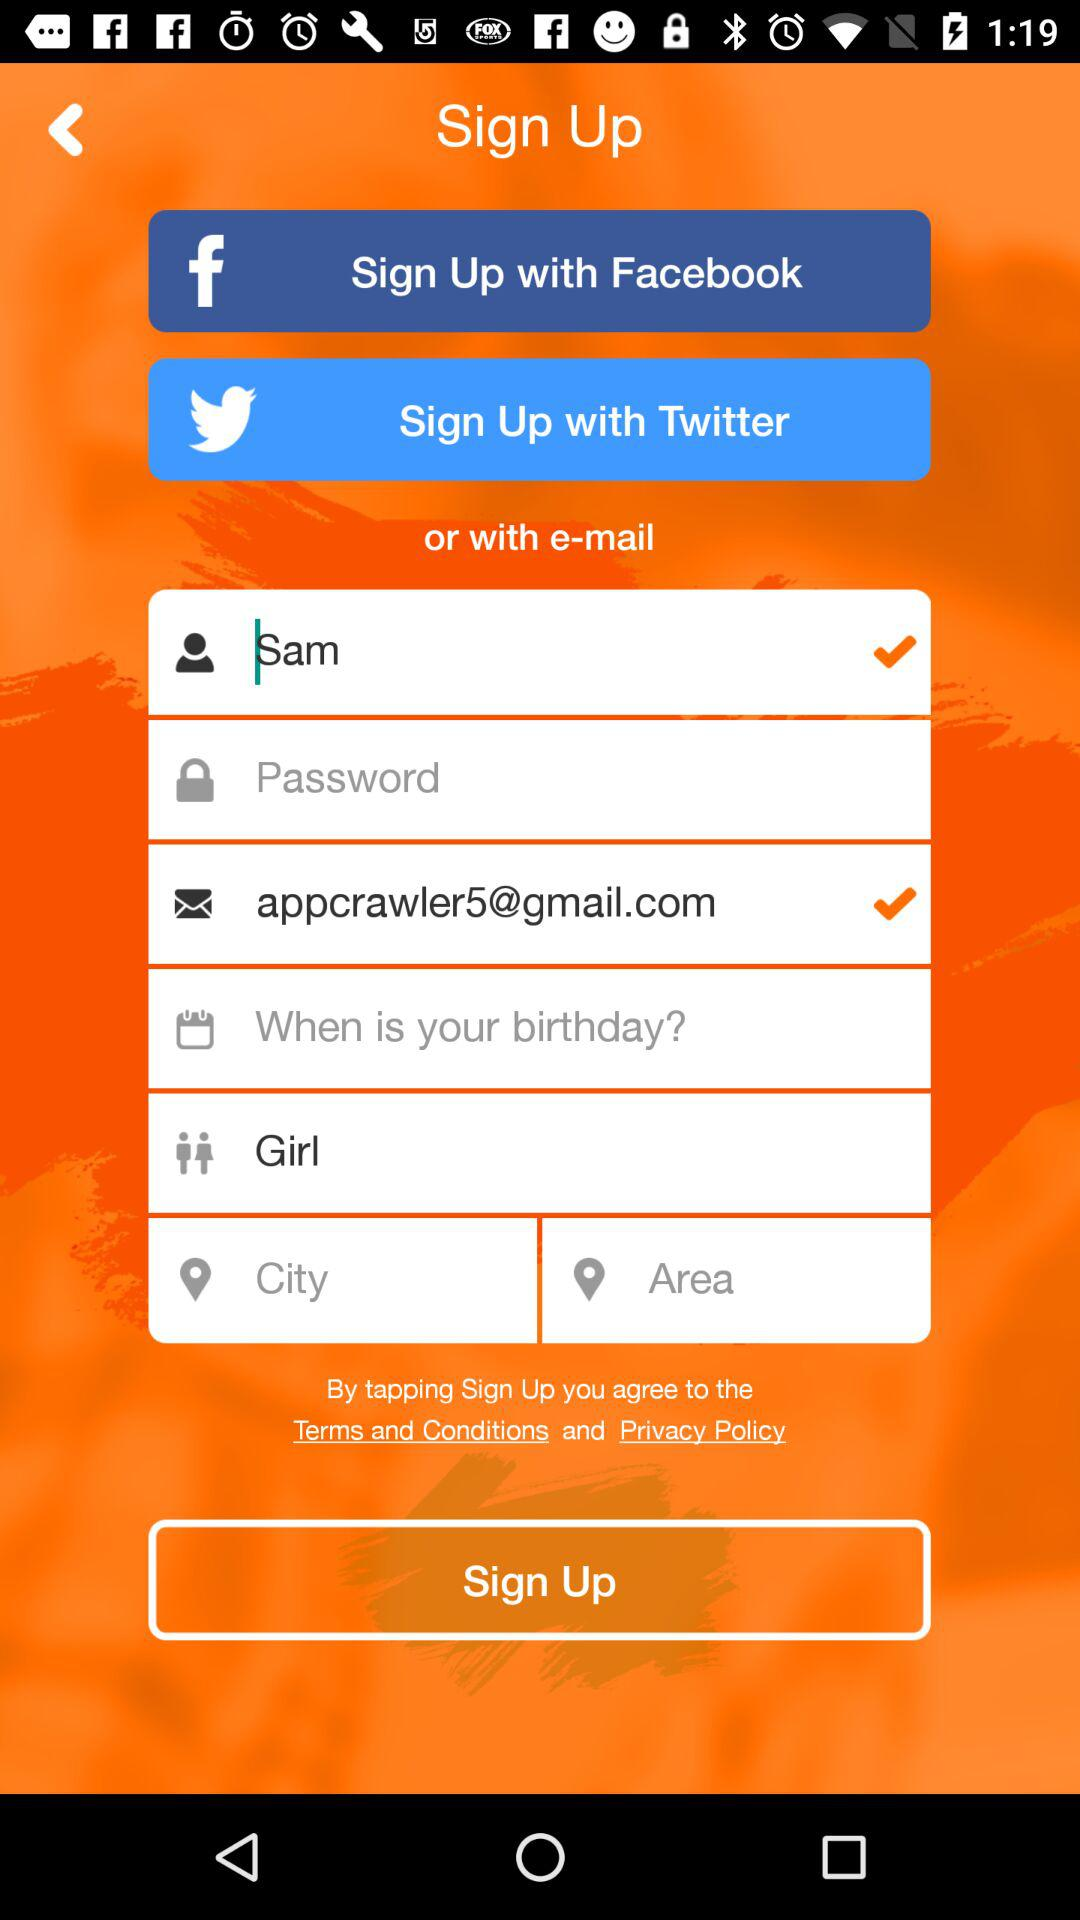Which other applications are given for signing up? The other applications are "Facebook" and "Twitter". 